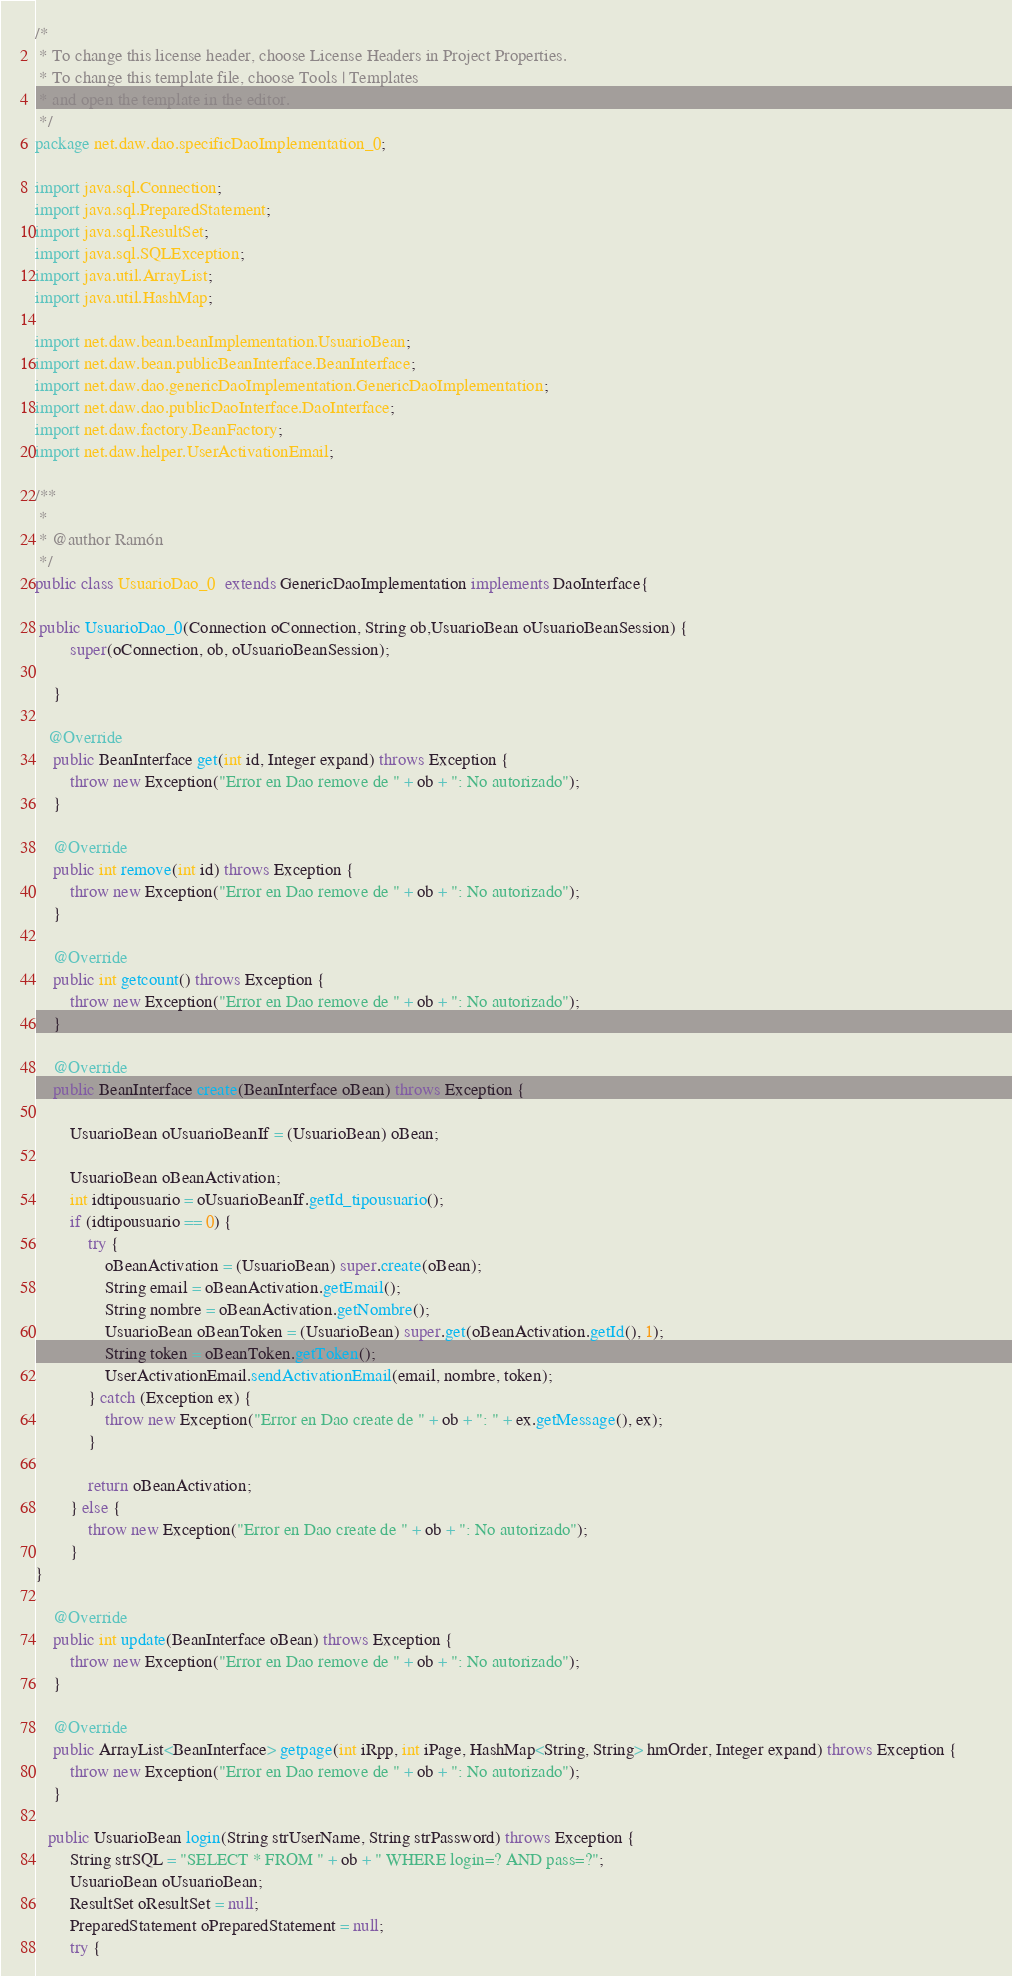Convert code to text. <code><loc_0><loc_0><loc_500><loc_500><_Java_>/*
 * To change this license header, choose License Headers in Project Properties.
 * To change this template file, choose Tools | Templates
 * and open the template in the editor.
 */
package net.daw.dao.specificDaoImplementation_0;

import java.sql.Connection;
import java.sql.PreparedStatement;
import java.sql.ResultSet;
import java.sql.SQLException;
import java.util.ArrayList;
import java.util.HashMap;

import net.daw.bean.beanImplementation.UsuarioBean;
import net.daw.bean.publicBeanInterface.BeanInterface;
import net.daw.dao.genericDaoImplementation.GenericDaoImplementation;
import net.daw.dao.publicDaoInterface.DaoInterface;
import net.daw.factory.BeanFactory;
import net.daw.helper.UserActivationEmail;

/**
 *
 * @author Ramón
 */
public class UsuarioDao_0  extends GenericDaoImplementation implements DaoInterface{

 public UsuarioDao_0(Connection oConnection, String ob,UsuarioBean oUsuarioBeanSession) {
        super(oConnection, ob, oUsuarioBeanSession);

    }
 
   @Override
    public BeanInterface get(int id, Integer expand) throws Exception {
        throw new Exception("Error en Dao remove de " + ob + ": No autorizado");
    }

    @Override
    public int remove(int id) throws Exception {
        throw new Exception("Error en Dao remove de " + ob + ": No autorizado");
    }

    @Override
    public int getcount() throws Exception {
        throw new Exception("Error en Dao remove de " + ob + ": No autorizado");
    }

    @Override
    public BeanInterface create(BeanInterface oBean) throws Exception {
        
        UsuarioBean oUsuarioBeanIf = (UsuarioBean) oBean;
        
        UsuarioBean oBeanActivation;
        int idtipousuario = oUsuarioBeanIf.getId_tipousuario();
        if (idtipousuario == 0) {
            try {
                oBeanActivation = (UsuarioBean) super.create(oBean);
                String email = oBeanActivation.getEmail();
                String nombre = oBeanActivation.getNombre();
                UsuarioBean oBeanToken = (UsuarioBean) super.get(oBeanActivation.getId(), 1);
                String token = oBeanToken.getToken();
                UserActivationEmail.sendActivationEmail(email, nombre, token);
            } catch (Exception ex) {
                throw new Exception("Error en Dao create de " + ob + ": " + ex.getMessage(), ex);
            }

            return oBeanActivation;
        } else {
            throw new Exception("Error en Dao create de " + ob + ": No autorizado");
        }
}

    @Override
    public int update(BeanInterface oBean) throws Exception {
        throw new Exception("Error en Dao remove de " + ob + ": No autorizado");
    }

    @Override
    public ArrayList<BeanInterface> getpage(int iRpp, int iPage, HashMap<String, String> hmOrder, Integer expand) throws Exception {        
        throw new Exception("Error en Dao remove de " + ob + ": No autorizado");
    }

   public UsuarioBean login(String strUserName, String strPassword) throws Exception {
        String strSQL = "SELECT * FROM " + ob + " WHERE login=? AND pass=?";
        UsuarioBean oUsuarioBean;
        ResultSet oResultSet = null;
        PreparedStatement oPreparedStatement = null;
        try {</code> 